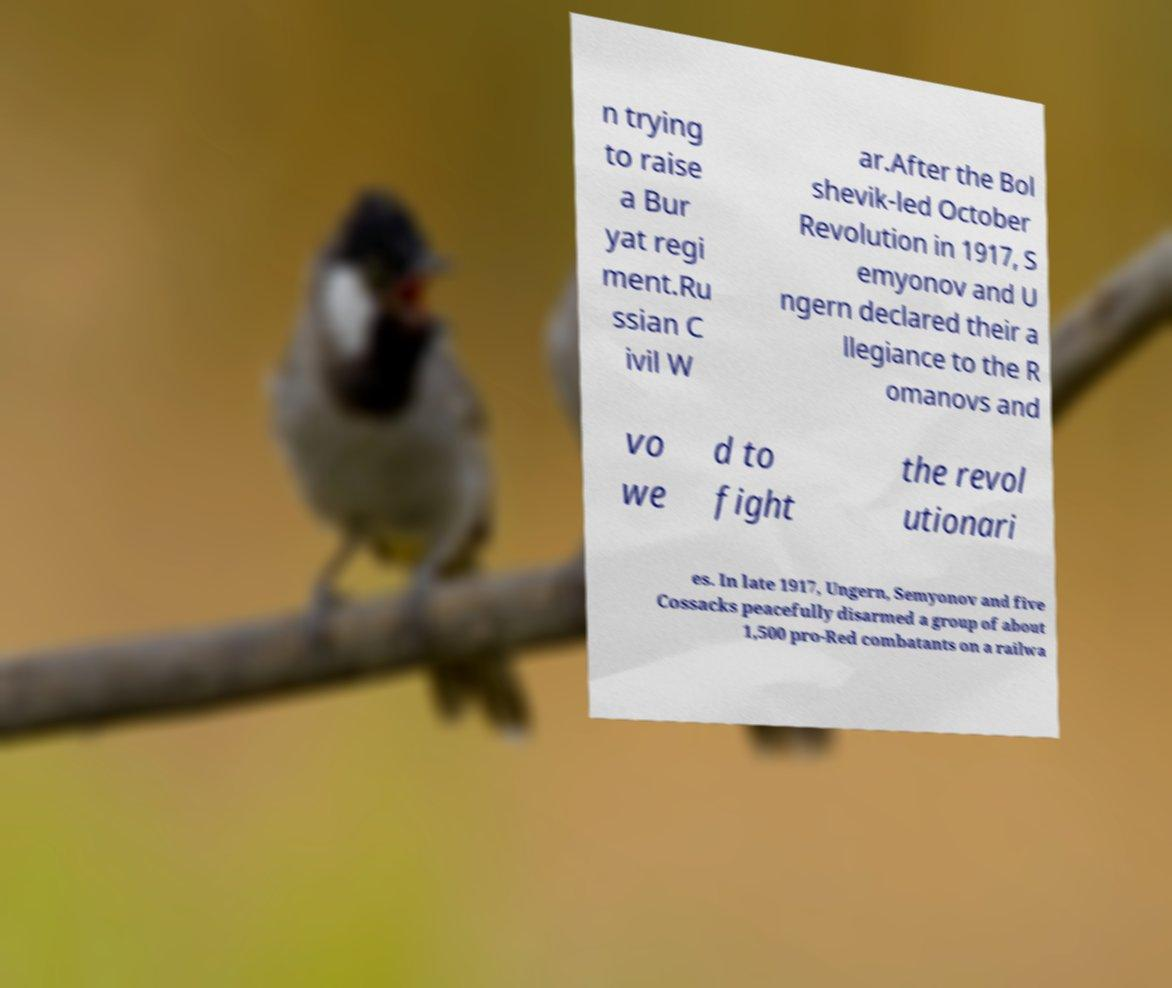What messages or text are displayed in this image? I need them in a readable, typed format. n trying to raise a Bur yat regi ment.Ru ssian C ivil W ar.After the Bol shevik-led October Revolution in 1917, S emyonov and U ngern declared their a llegiance to the R omanovs and vo we d to fight the revol utionari es. In late 1917, Ungern, Semyonov and five Cossacks peacefully disarmed a group of about 1,500 pro-Red combatants on a railwa 